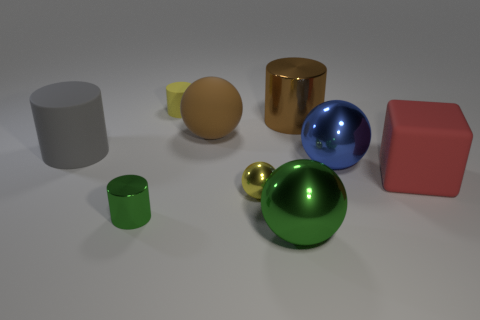Are there more yellow balls that are to the left of the tiny yellow shiny thing than large rubber cylinders that are in front of the brown matte ball?
Give a very brief answer. No. Is there any other thing of the same color as the rubber ball?
Ensure brevity in your answer.  Yes. What number of things are either purple metal spheres or big rubber blocks?
Offer a terse response. 1. There is a green metallic thing that is in front of the green metallic cylinder; does it have the same size as the tiny yellow cylinder?
Make the answer very short. No. What number of other things are the same size as the yellow shiny ball?
Ensure brevity in your answer.  2. Are any large brown rubber spheres visible?
Your answer should be compact. Yes. How big is the block that is to the right of the shiny cylinder behind the blue metal sphere?
Offer a terse response. Large. There is a big matte thing on the left side of the small green shiny cylinder; does it have the same color as the large shiny thing in front of the tiny green metal cylinder?
Your answer should be very brief. No. What is the color of the metallic ball that is both in front of the red cube and behind the green shiny cylinder?
Your answer should be compact. Yellow. What number of other things are there of the same shape as the yellow rubber object?
Offer a very short reply. 3. 